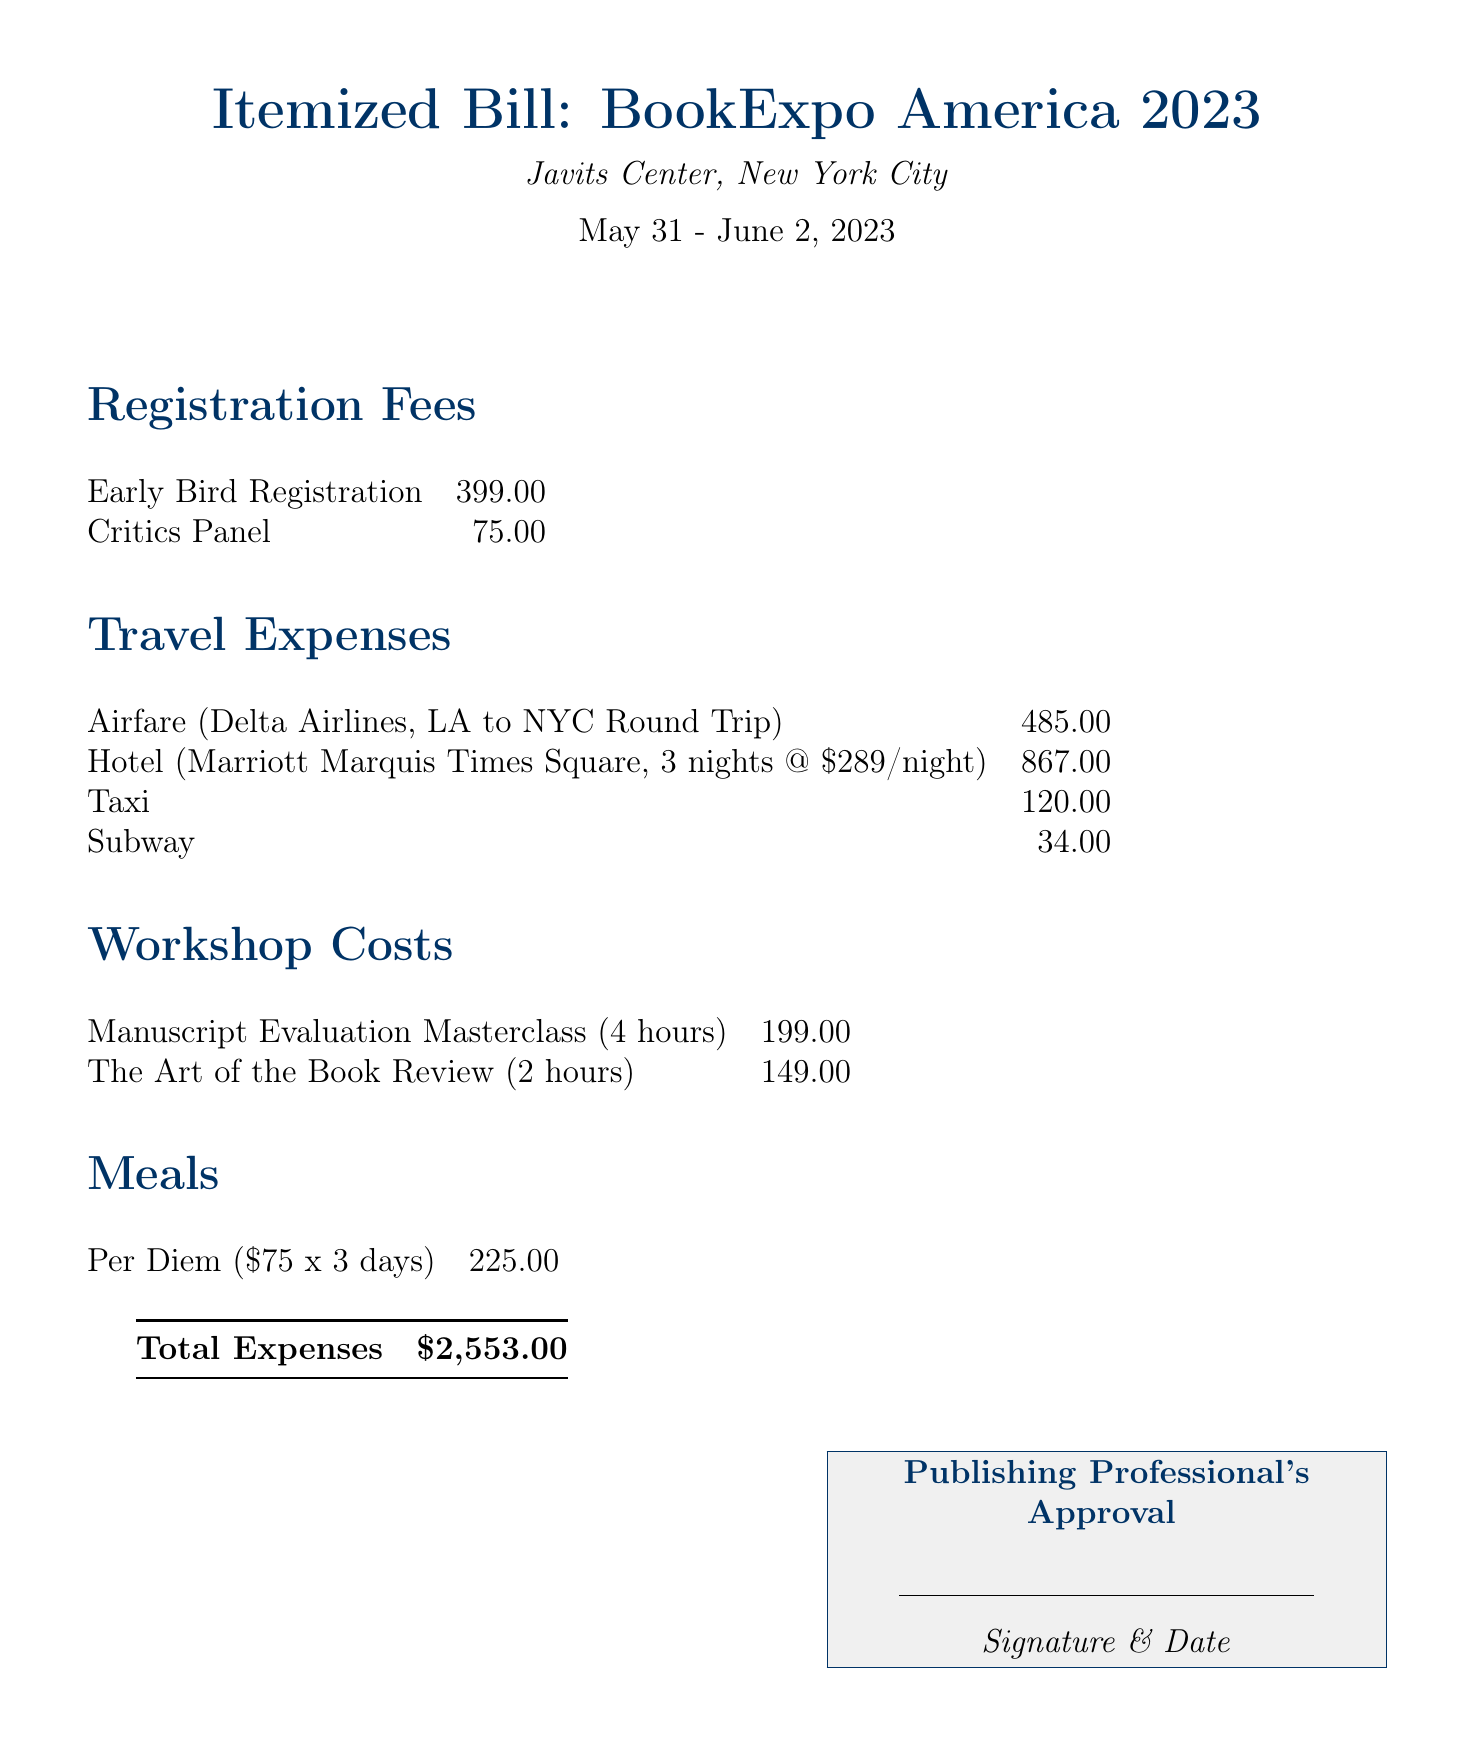What is the total amount of the bill? The total amount of the bill is stated at the bottom of the document, which includes all the expenses.
Answer: $2,553.00 What is the location of the conference? The document specifies that the conference took place at the Javits Center in New York City.
Answer: Javits Center, New York City How much was the early bird registration fee? The early bird registration fee is listed under the registration fees section of the document.
Answer: 399.00 How many nights did the hotel stay cover? The hotel expenses indicate that the stay was for three nights at the Marriott Marquis Times Square.
Answer: 3 nights What was the cost of the Manuscript Evaluation Masterclass? The cost of the Manuscript Evaluation Masterclass can be found in the workshop costs section of the bill.
Answer: 199.00 What was the total airfare expense? The airfare expense is listed under travel expenses and specifies the cost for the round trip from Los Angeles to New York City.
Answer: 485.00 How much was the per diem for meals? The document specifies that the per diem is calculated at $75 per day over three days.
Answer: 225.00 What transportation methods are mentioned in the bill? The document lists taxi and subway as the two modes of transportation expenses incurred.
Answer: Taxi, Subway What is the signature requirement indicated in the document? The document includes a section requiring the signature and date from the publishing professional for approval.
Answer: Signature & Date 